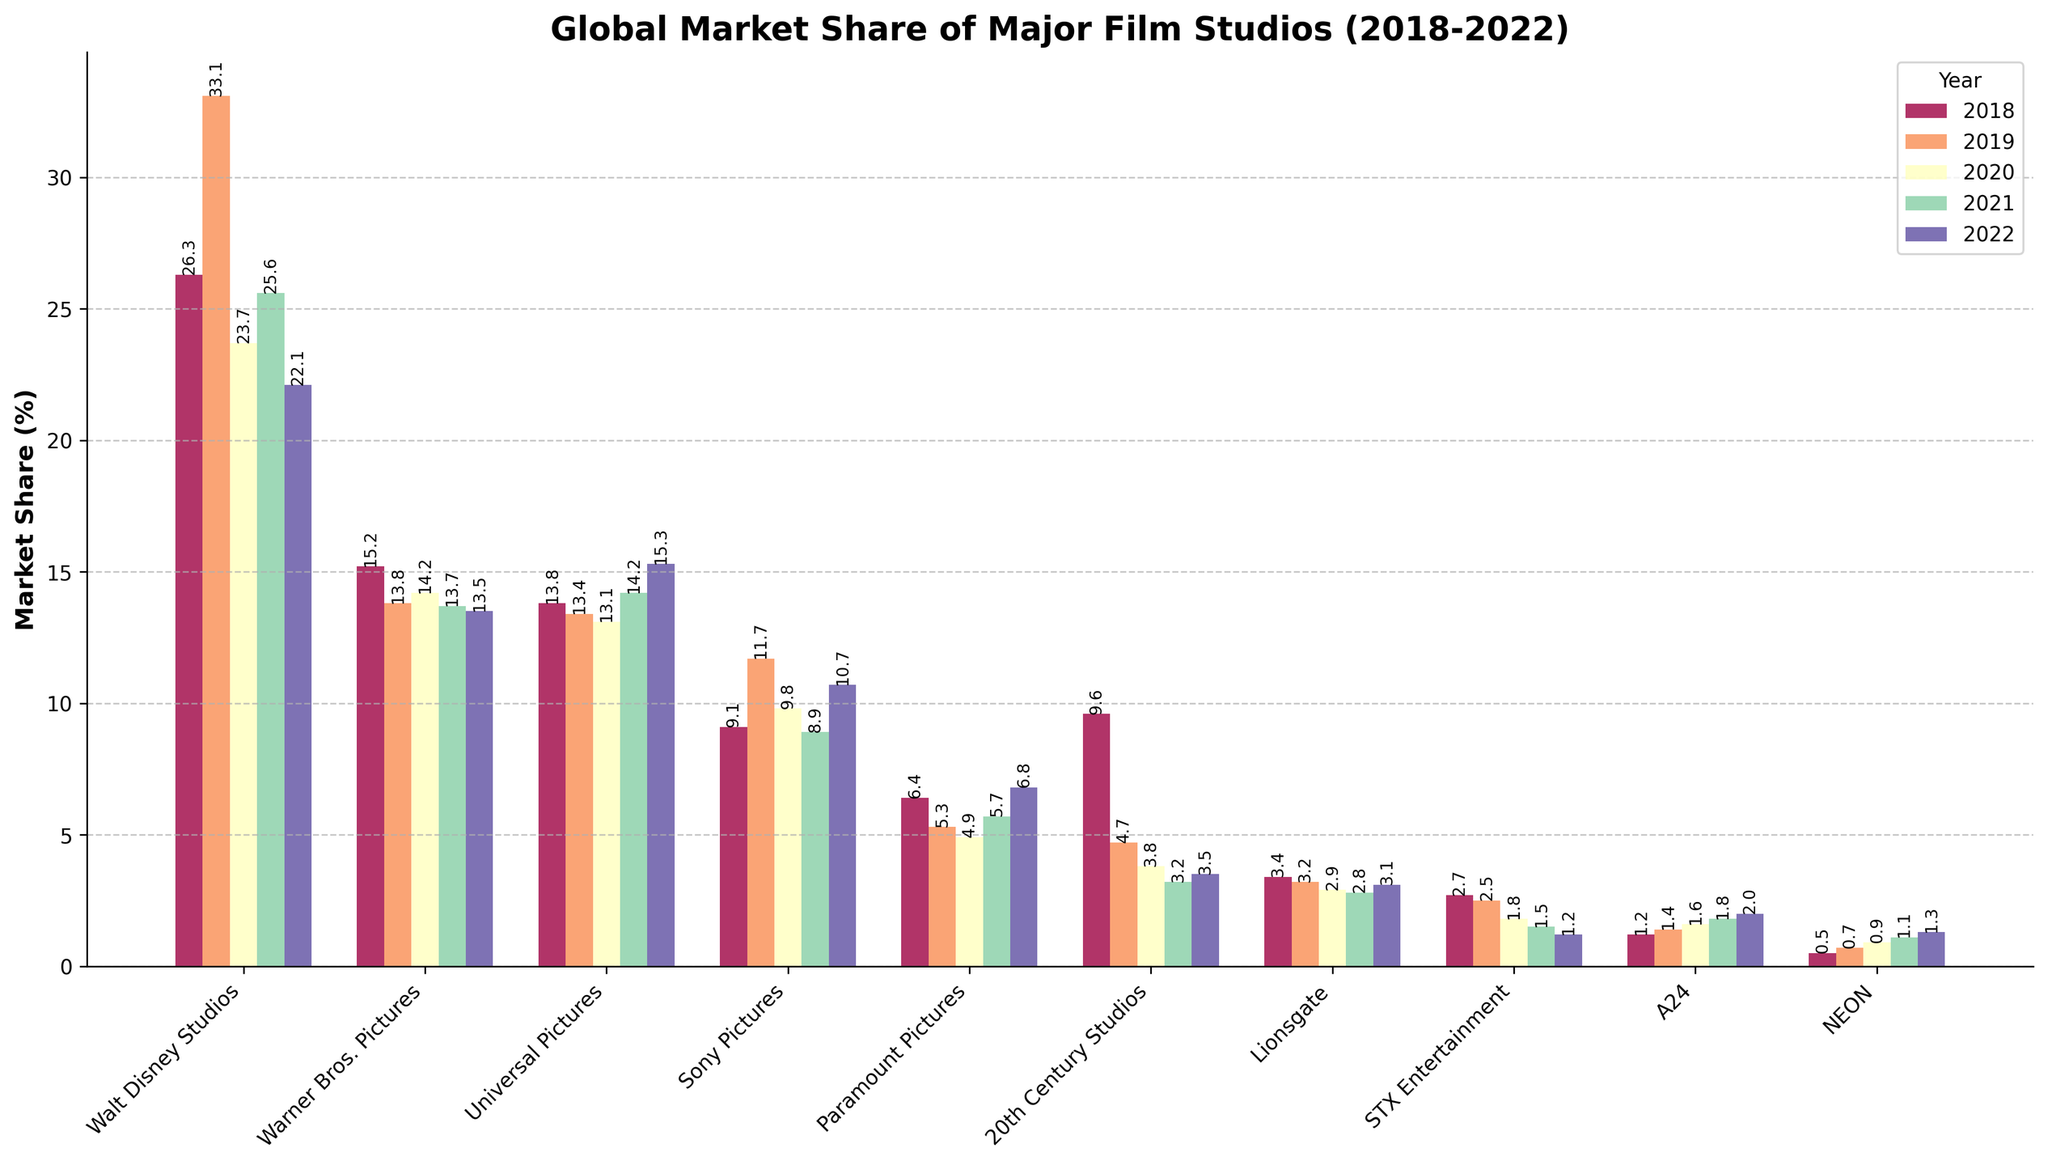Which studio had the highest market share in 2019? Look at the bar heights for the year 2019. Walt Disney Studios has the tallest bar, indicating the highest market share.
Answer: Walt Disney Studios How did the market share of Universal Pictures change from 2018 to 2022? Go through the bars representing Universal Pictures from 2018 to 2022 and observe the changes. The market share increased from 13.8% in 2018 to 15.3% in 2022.
Answer: Increased Which studio had the most consistent market share over the 5 years? Find the studio with the least variation in bar heights across all years. Warner Bros. Pictures shows the least annual fluctuation.
Answer: Warner Bros. Pictures In 2020, between Sony Pictures and Paramount Pictures, which had a higher market share? Compare the bar heights of Sony Pictures and Paramount Pictures in 2020. Sony Pictures has a higher bar.
Answer: Sony Pictures Which studio had the lowest market share in 2022? Find the shortest bar for the year 2022. STX Entertainment has the shortest bar, indicating the lowest market share.
Answer: STX Entertainment What’s the average market share of Walt Disney Studios over the 5 years? Calculate the average of Walt Disney Studios’ market shares from 2018 to 2022: (26.3 + 33.1 + 23.7 + 25.6 + 22.1) / 5 = 26.16
Answer: 26.16 Which year had the highest total market share for the top 3 studios combined? Sum the market shares of the top 3 studios (Walt Disney Studios, Warner Bros. Pictures, and Universal Pictures) for each year and compare them. 2019 had the highest with a total of 62.9% (33.1 + 13.8 + 13.4).
Answer: 2019 What is the difference in market share between 20th Century Studios and A24 in 2021? Subtract the market share of A24 from 20th Century Studios for 2021: 3.2 - 1.8 = 1.4
Answer: 1.4 Which studio showed the largest increase in market share from 2021 to 2022? Calculate the difference in market share for each studio between 2021 and 2022, then identify the largest. Universal Pictures increased by 1.1% (15.3 - 14.2).
Answer: Universal Pictures What is the combined market share of NEON from 2018 to 2022? Sum NEON’s market shares from 2018 to 2022: 0.5 + 0.7 + 0.9 + 1.1 + 1.3 = 4.5
Answer: 4.5 What are the average market shares of the studios in 2018? Calculate the average of the market shares of all studios for 2018: (26.3 + 15.2 + 13.8 + 9.1 + 6.4 + 9.6 + 3.4 + 2.7 + 1.2 + 0.5) / 10 = 8.42
Answer: 8.42 